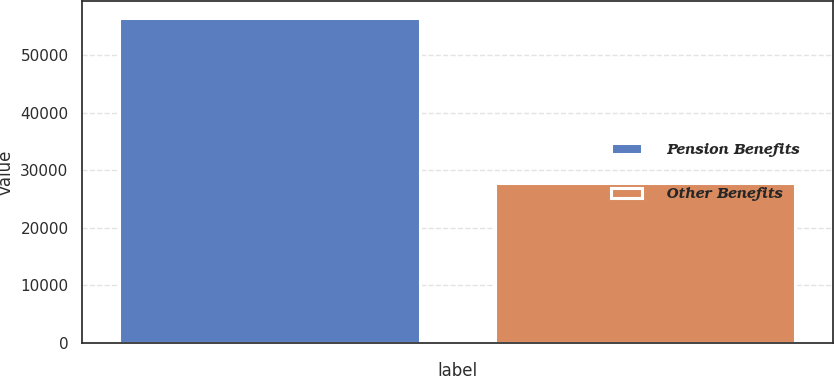<chart> <loc_0><loc_0><loc_500><loc_500><bar_chart><fcel>Pension Benefits<fcel>Other Benefits<nl><fcel>56544<fcel>27735<nl></chart> 